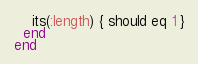<code> <loc_0><loc_0><loc_500><loc_500><_Ruby_>    its(:length) { should eq 1 }
  end
end
</code> 